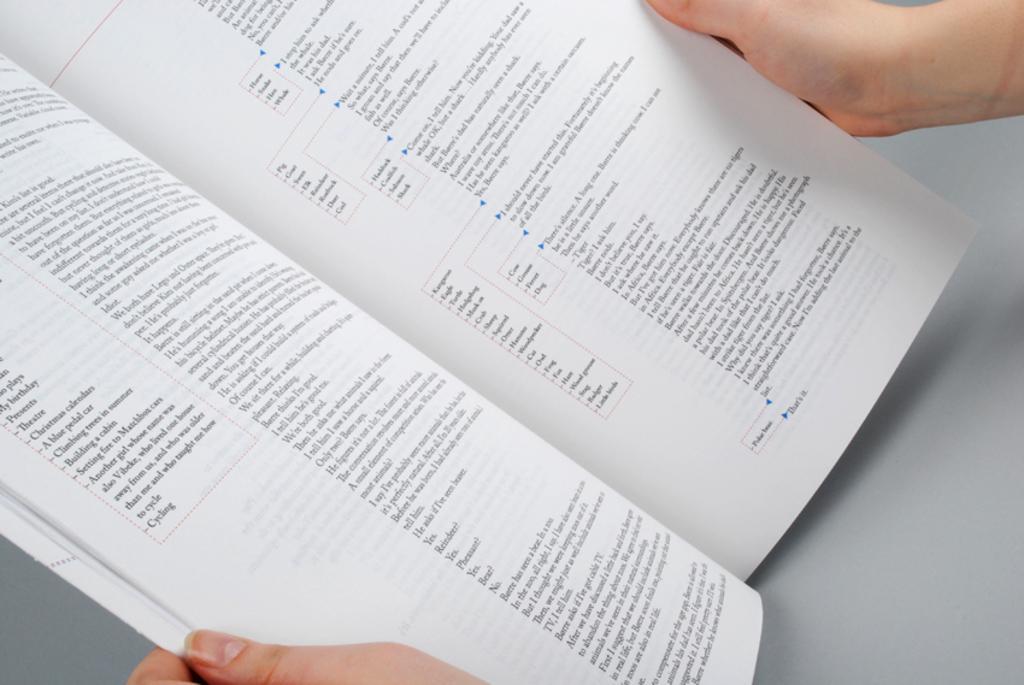In one or two sentences, can you explain what this image depicts? A person is holding an open book. 